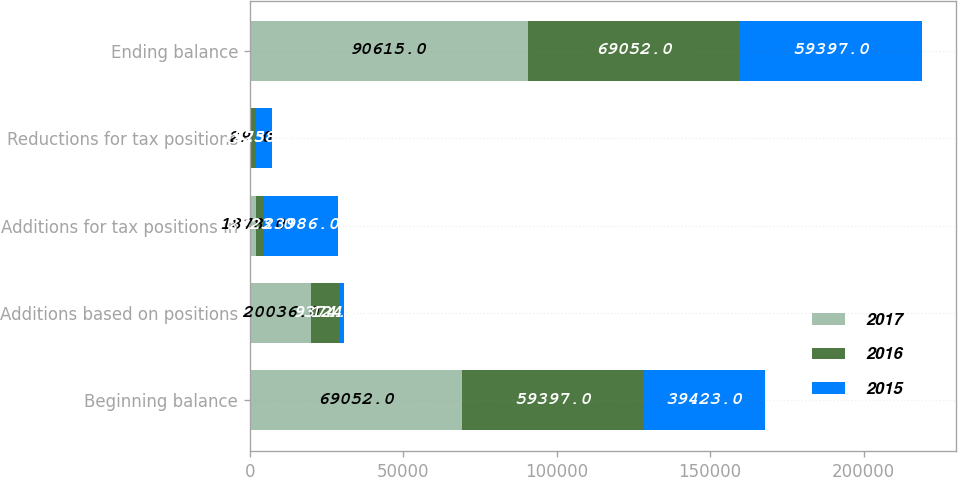<chart> <loc_0><loc_0><loc_500><loc_500><stacked_bar_chart><ecel><fcel>Beginning balance<fcel>Additions based on positions<fcel>Additions for tax positions in<fcel>Reductions for tax positions<fcel>Ending balance<nl><fcel>2017<fcel>69052<fcel>20036<fcel>1878<fcel>29<fcel>90615<nl><fcel>2016<fcel>59397<fcel>9374<fcel>2723<fcel>1973<fcel>69052<nl><fcel>2015<fcel>39423<fcel>1246<fcel>23986<fcel>5258<fcel>59397<nl></chart> 